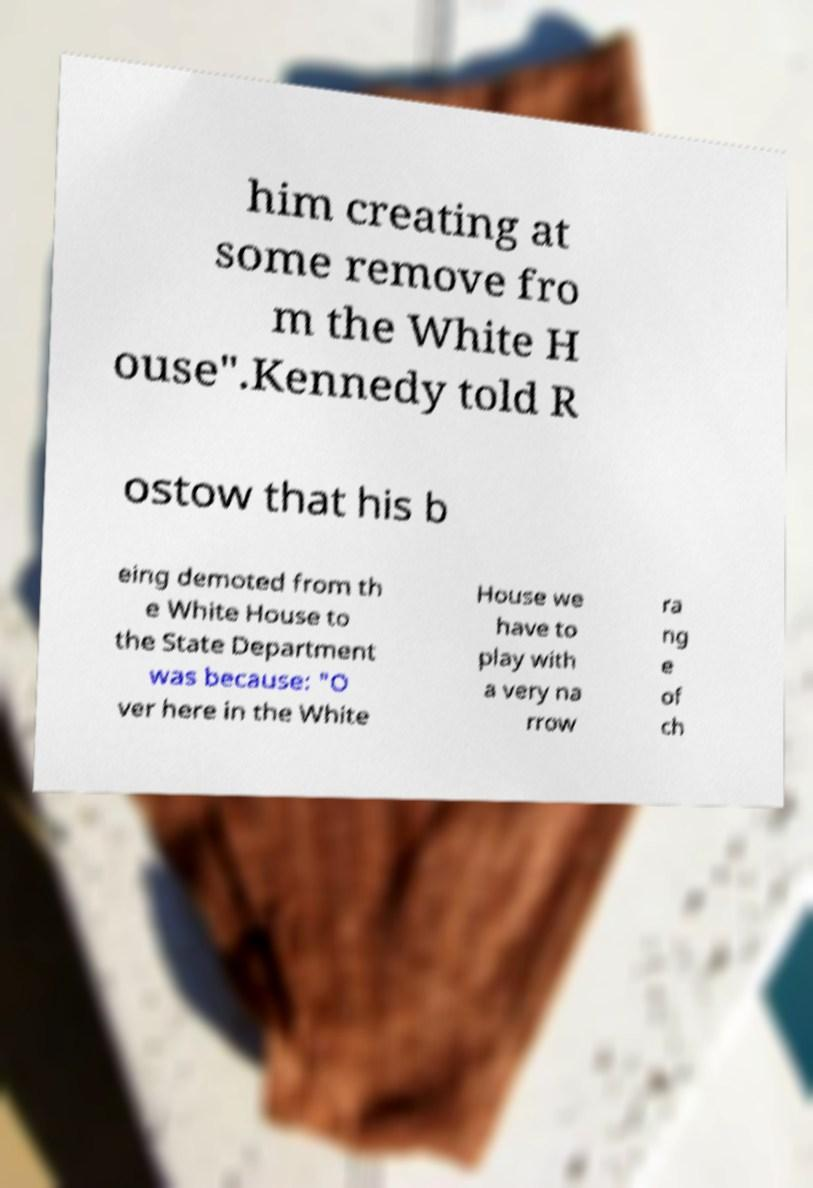For documentation purposes, I need the text within this image transcribed. Could you provide that? him creating at some remove fro m the White H ouse".Kennedy told R ostow that his b eing demoted from th e White House to the State Department was because: "O ver here in the White House we have to play with a very na rrow ra ng e of ch 